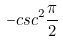<formula> <loc_0><loc_0><loc_500><loc_500>- c s c ^ { 2 } \frac { \pi } { 2 }</formula> 